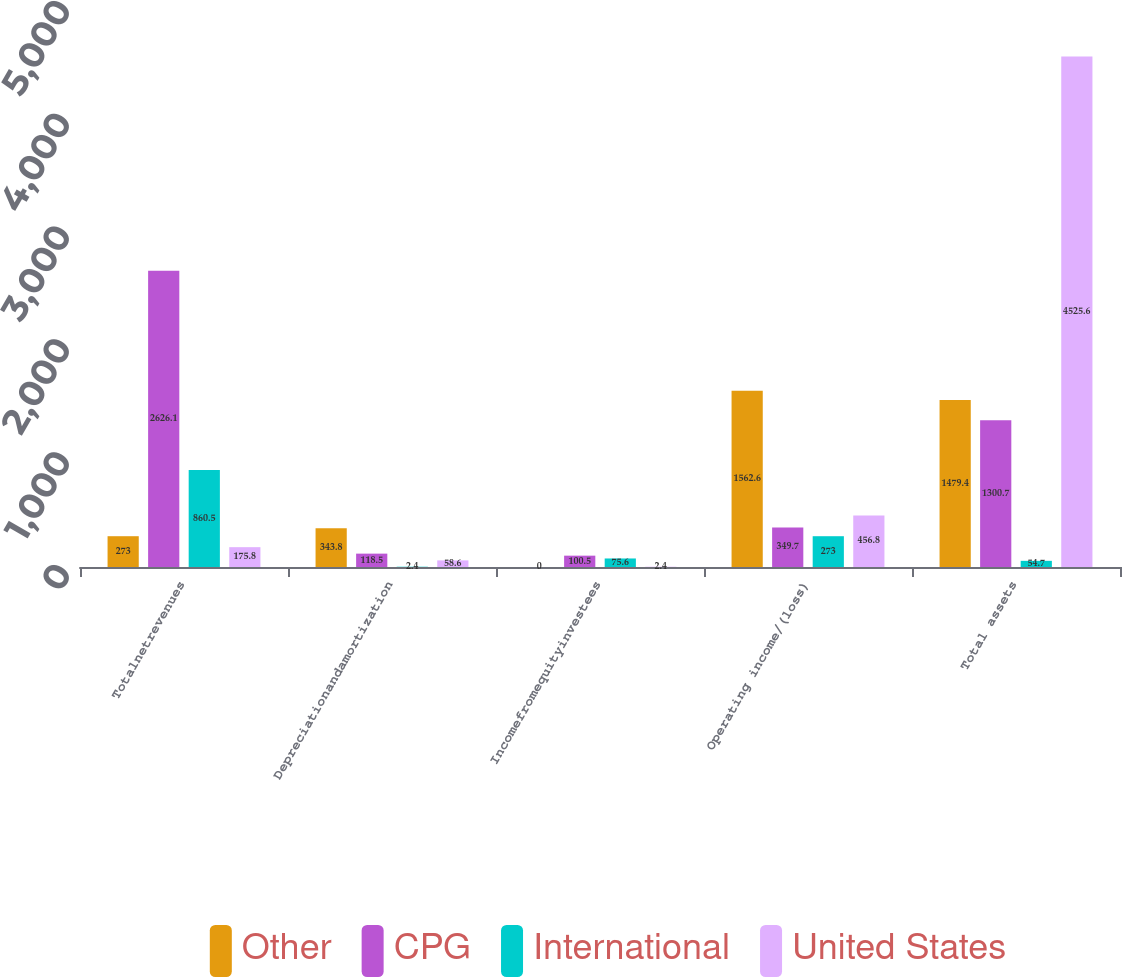Convert chart. <chart><loc_0><loc_0><loc_500><loc_500><stacked_bar_chart><ecel><fcel>Totalnetrevenues<fcel>Depreciationandamortization<fcel>Incomefromequityinvestees<fcel>Operating income/(loss)<fcel>Total assets<nl><fcel>Other<fcel>273<fcel>343.8<fcel>0<fcel>1562.6<fcel>1479.4<nl><fcel>CPG<fcel>2626.1<fcel>118.5<fcel>100.5<fcel>349.7<fcel>1300.7<nl><fcel>International<fcel>860.5<fcel>2.4<fcel>75.6<fcel>273<fcel>54.7<nl><fcel>United States<fcel>175.8<fcel>58.6<fcel>2.4<fcel>456.8<fcel>4525.6<nl></chart> 